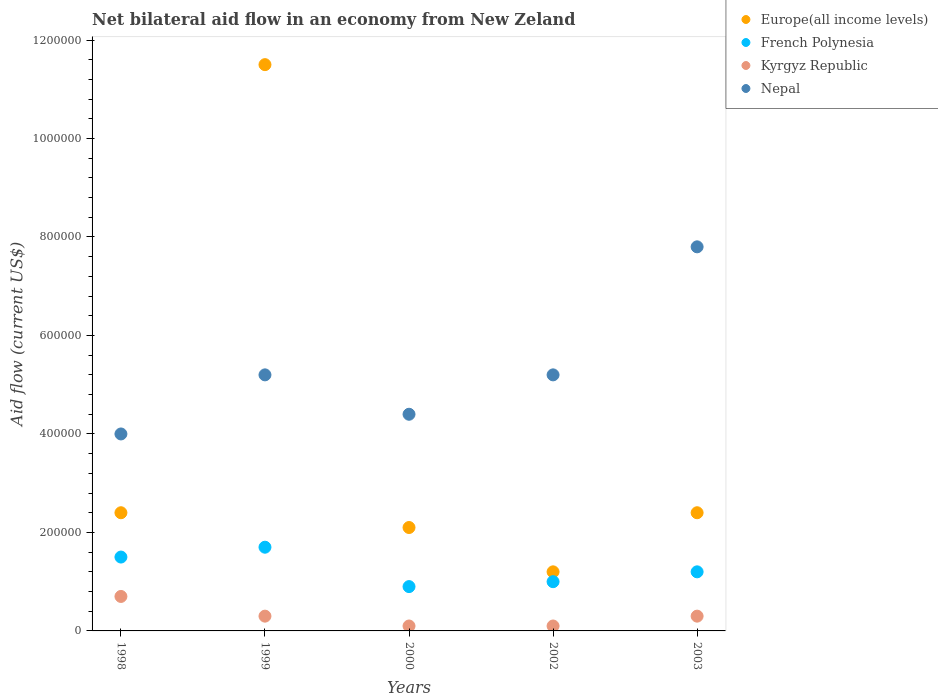Is the number of dotlines equal to the number of legend labels?
Your response must be concise. Yes. What is the net bilateral aid flow in Nepal in 1999?
Keep it short and to the point. 5.20e+05. Across all years, what is the maximum net bilateral aid flow in Kyrgyz Republic?
Provide a short and direct response. 7.00e+04. Across all years, what is the minimum net bilateral aid flow in Nepal?
Offer a very short reply. 4.00e+05. In which year was the net bilateral aid flow in Nepal minimum?
Offer a very short reply. 1998. What is the total net bilateral aid flow in Europe(all income levels) in the graph?
Your response must be concise. 1.96e+06. What is the difference between the net bilateral aid flow in French Polynesia in 2002 and the net bilateral aid flow in Nepal in 1999?
Your answer should be compact. -4.20e+05. What is the average net bilateral aid flow in Kyrgyz Republic per year?
Provide a short and direct response. 3.00e+04. In the year 2000, what is the difference between the net bilateral aid flow in French Polynesia and net bilateral aid flow in Europe(all income levels)?
Offer a very short reply. -1.20e+05. What is the ratio of the net bilateral aid flow in Kyrgyz Republic in 2000 to that in 2003?
Provide a short and direct response. 0.33. Is the net bilateral aid flow in Kyrgyz Republic in 2002 less than that in 2003?
Provide a short and direct response. Yes. What is the difference between the highest and the second highest net bilateral aid flow in French Polynesia?
Your answer should be very brief. 2.00e+04. What is the difference between the highest and the lowest net bilateral aid flow in Kyrgyz Republic?
Make the answer very short. 6.00e+04. In how many years, is the net bilateral aid flow in Nepal greater than the average net bilateral aid flow in Nepal taken over all years?
Your answer should be very brief. 1. Is it the case that in every year, the sum of the net bilateral aid flow in Nepal and net bilateral aid flow in Europe(all income levels)  is greater than the net bilateral aid flow in Kyrgyz Republic?
Provide a succinct answer. Yes. Does the net bilateral aid flow in Europe(all income levels) monotonically increase over the years?
Your answer should be very brief. No. Is the net bilateral aid flow in French Polynesia strictly greater than the net bilateral aid flow in Europe(all income levels) over the years?
Your answer should be compact. No. How many dotlines are there?
Ensure brevity in your answer.  4. What is the difference between two consecutive major ticks on the Y-axis?
Offer a very short reply. 2.00e+05. Does the graph contain grids?
Ensure brevity in your answer.  No. Where does the legend appear in the graph?
Keep it short and to the point. Top right. What is the title of the graph?
Offer a terse response. Net bilateral aid flow in an economy from New Zeland. What is the label or title of the X-axis?
Give a very brief answer. Years. What is the Aid flow (current US$) in Kyrgyz Republic in 1998?
Your response must be concise. 7.00e+04. What is the Aid flow (current US$) in Europe(all income levels) in 1999?
Your answer should be compact. 1.15e+06. What is the Aid flow (current US$) in French Polynesia in 1999?
Offer a terse response. 1.70e+05. What is the Aid flow (current US$) of Kyrgyz Republic in 1999?
Provide a succinct answer. 3.00e+04. What is the Aid flow (current US$) of Nepal in 1999?
Provide a succinct answer. 5.20e+05. What is the Aid flow (current US$) of Kyrgyz Republic in 2000?
Offer a terse response. 10000. What is the Aid flow (current US$) of French Polynesia in 2002?
Provide a short and direct response. 1.00e+05. What is the Aid flow (current US$) of Kyrgyz Republic in 2002?
Ensure brevity in your answer.  10000. What is the Aid flow (current US$) in Nepal in 2002?
Keep it short and to the point. 5.20e+05. What is the Aid flow (current US$) in Nepal in 2003?
Your answer should be compact. 7.80e+05. Across all years, what is the maximum Aid flow (current US$) of Europe(all income levels)?
Ensure brevity in your answer.  1.15e+06. Across all years, what is the maximum Aid flow (current US$) of French Polynesia?
Give a very brief answer. 1.70e+05. Across all years, what is the maximum Aid flow (current US$) of Kyrgyz Republic?
Offer a very short reply. 7.00e+04. Across all years, what is the maximum Aid flow (current US$) in Nepal?
Offer a terse response. 7.80e+05. Across all years, what is the minimum Aid flow (current US$) in French Polynesia?
Offer a very short reply. 9.00e+04. Across all years, what is the minimum Aid flow (current US$) in Kyrgyz Republic?
Keep it short and to the point. 10000. What is the total Aid flow (current US$) of Europe(all income levels) in the graph?
Your response must be concise. 1.96e+06. What is the total Aid flow (current US$) in French Polynesia in the graph?
Offer a very short reply. 6.30e+05. What is the total Aid flow (current US$) of Kyrgyz Republic in the graph?
Keep it short and to the point. 1.50e+05. What is the total Aid flow (current US$) of Nepal in the graph?
Give a very brief answer. 2.66e+06. What is the difference between the Aid flow (current US$) in Europe(all income levels) in 1998 and that in 1999?
Your response must be concise. -9.10e+05. What is the difference between the Aid flow (current US$) of Kyrgyz Republic in 1998 and that in 1999?
Keep it short and to the point. 4.00e+04. What is the difference between the Aid flow (current US$) in Nepal in 1998 and that in 1999?
Your response must be concise. -1.20e+05. What is the difference between the Aid flow (current US$) in French Polynesia in 1998 and that in 2000?
Provide a short and direct response. 6.00e+04. What is the difference between the Aid flow (current US$) of Kyrgyz Republic in 1998 and that in 2000?
Give a very brief answer. 6.00e+04. What is the difference between the Aid flow (current US$) in Nepal in 1998 and that in 2000?
Ensure brevity in your answer.  -4.00e+04. What is the difference between the Aid flow (current US$) of Europe(all income levels) in 1998 and that in 2002?
Your answer should be compact. 1.20e+05. What is the difference between the Aid flow (current US$) of French Polynesia in 1998 and that in 2002?
Your answer should be very brief. 5.00e+04. What is the difference between the Aid flow (current US$) in Kyrgyz Republic in 1998 and that in 2002?
Give a very brief answer. 6.00e+04. What is the difference between the Aid flow (current US$) of Nepal in 1998 and that in 2002?
Your answer should be compact. -1.20e+05. What is the difference between the Aid flow (current US$) of Nepal in 1998 and that in 2003?
Offer a terse response. -3.80e+05. What is the difference between the Aid flow (current US$) in Europe(all income levels) in 1999 and that in 2000?
Offer a terse response. 9.40e+05. What is the difference between the Aid flow (current US$) in French Polynesia in 1999 and that in 2000?
Your answer should be compact. 8.00e+04. What is the difference between the Aid flow (current US$) in Kyrgyz Republic in 1999 and that in 2000?
Your response must be concise. 2.00e+04. What is the difference between the Aid flow (current US$) of Europe(all income levels) in 1999 and that in 2002?
Your response must be concise. 1.03e+06. What is the difference between the Aid flow (current US$) in Nepal in 1999 and that in 2002?
Offer a terse response. 0. What is the difference between the Aid flow (current US$) of Europe(all income levels) in 1999 and that in 2003?
Offer a very short reply. 9.10e+05. What is the difference between the Aid flow (current US$) of French Polynesia in 1999 and that in 2003?
Provide a short and direct response. 5.00e+04. What is the difference between the Aid flow (current US$) in Kyrgyz Republic in 1999 and that in 2003?
Offer a terse response. 0. What is the difference between the Aid flow (current US$) of Europe(all income levels) in 2000 and that in 2002?
Offer a terse response. 9.00e+04. What is the difference between the Aid flow (current US$) of French Polynesia in 2000 and that in 2002?
Make the answer very short. -10000. What is the difference between the Aid flow (current US$) in Kyrgyz Republic in 2000 and that in 2002?
Provide a succinct answer. 0. What is the difference between the Aid flow (current US$) in Nepal in 2000 and that in 2002?
Make the answer very short. -8.00e+04. What is the difference between the Aid flow (current US$) of Kyrgyz Republic in 2000 and that in 2003?
Offer a very short reply. -2.00e+04. What is the difference between the Aid flow (current US$) of Nepal in 2000 and that in 2003?
Provide a short and direct response. -3.40e+05. What is the difference between the Aid flow (current US$) in Europe(all income levels) in 2002 and that in 2003?
Ensure brevity in your answer.  -1.20e+05. What is the difference between the Aid flow (current US$) in Nepal in 2002 and that in 2003?
Provide a succinct answer. -2.60e+05. What is the difference between the Aid flow (current US$) in Europe(all income levels) in 1998 and the Aid flow (current US$) in French Polynesia in 1999?
Give a very brief answer. 7.00e+04. What is the difference between the Aid flow (current US$) of Europe(all income levels) in 1998 and the Aid flow (current US$) of Nepal in 1999?
Offer a terse response. -2.80e+05. What is the difference between the Aid flow (current US$) in French Polynesia in 1998 and the Aid flow (current US$) in Kyrgyz Republic in 1999?
Keep it short and to the point. 1.20e+05. What is the difference between the Aid flow (current US$) in French Polynesia in 1998 and the Aid flow (current US$) in Nepal in 1999?
Keep it short and to the point. -3.70e+05. What is the difference between the Aid flow (current US$) in Kyrgyz Republic in 1998 and the Aid flow (current US$) in Nepal in 1999?
Your answer should be very brief. -4.50e+05. What is the difference between the Aid flow (current US$) in Europe(all income levels) in 1998 and the Aid flow (current US$) in Nepal in 2000?
Offer a very short reply. -2.00e+05. What is the difference between the Aid flow (current US$) in French Polynesia in 1998 and the Aid flow (current US$) in Nepal in 2000?
Ensure brevity in your answer.  -2.90e+05. What is the difference between the Aid flow (current US$) in Kyrgyz Republic in 1998 and the Aid flow (current US$) in Nepal in 2000?
Your answer should be compact. -3.70e+05. What is the difference between the Aid flow (current US$) of Europe(all income levels) in 1998 and the Aid flow (current US$) of Nepal in 2002?
Your response must be concise. -2.80e+05. What is the difference between the Aid flow (current US$) in French Polynesia in 1998 and the Aid flow (current US$) in Kyrgyz Republic in 2002?
Your response must be concise. 1.40e+05. What is the difference between the Aid flow (current US$) in French Polynesia in 1998 and the Aid flow (current US$) in Nepal in 2002?
Offer a very short reply. -3.70e+05. What is the difference between the Aid flow (current US$) of Kyrgyz Republic in 1998 and the Aid flow (current US$) of Nepal in 2002?
Offer a terse response. -4.50e+05. What is the difference between the Aid flow (current US$) in Europe(all income levels) in 1998 and the Aid flow (current US$) in French Polynesia in 2003?
Provide a succinct answer. 1.20e+05. What is the difference between the Aid flow (current US$) of Europe(all income levels) in 1998 and the Aid flow (current US$) of Nepal in 2003?
Your response must be concise. -5.40e+05. What is the difference between the Aid flow (current US$) of French Polynesia in 1998 and the Aid flow (current US$) of Nepal in 2003?
Give a very brief answer. -6.30e+05. What is the difference between the Aid flow (current US$) in Kyrgyz Republic in 1998 and the Aid flow (current US$) in Nepal in 2003?
Provide a succinct answer. -7.10e+05. What is the difference between the Aid flow (current US$) of Europe(all income levels) in 1999 and the Aid flow (current US$) of French Polynesia in 2000?
Provide a short and direct response. 1.06e+06. What is the difference between the Aid flow (current US$) of Europe(all income levels) in 1999 and the Aid flow (current US$) of Kyrgyz Republic in 2000?
Your answer should be very brief. 1.14e+06. What is the difference between the Aid flow (current US$) of Europe(all income levels) in 1999 and the Aid flow (current US$) of Nepal in 2000?
Offer a very short reply. 7.10e+05. What is the difference between the Aid flow (current US$) of French Polynesia in 1999 and the Aid flow (current US$) of Nepal in 2000?
Make the answer very short. -2.70e+05. What is the difference between the Aid flow (current US$) of Kyrgyz Republic in 1999 and the Aid flow (current US$) of Nepal in 2000?
Offer a very short reply. -4.10e+05. What is the difference between the Aid flow (current US$) of Europe(all income levels) in 1999 and the Aid flow (current US$) of French Polynesia in 2002?
Your answer should be compact. 1.05e+06. What is the difference between the Aid flow (current US$) in Europe(all income levels) in 1999 and the Aid flow (current US$) in Kyrgyz Republic in 2002?
Offer a very short reply. 1.14e+06. What is the difference between the Aid flow (current US$) of Europe(all income levels) in 1999 and the Aid flow (current US$) of Nepal in 2002?
Provide a succinct answer. 6.30e+05. What is the difference between the Aid flow (current US$) in French Polynesia in 1999 and the Aid flow (current US$) in Nepal in 2002?
Provide a short and direct response. -3.50e+05. What is the difference between the Aid flow (current US$) in Kyrgyz Republic in 1999 and the Aid flow (current US$) in Nepal in 2002?
Give a very brief answer. -4.90e+05. What is the difference between the Aid flow (current US$) of Europe(all income levels) in 1999 and the Aid flow (current US$) of French Polynesia in 2003?
Offer a terse response. 1.03e+06. What is the difference between the Aid flow (current US$) of Europe(all income levels) in 1999 and the Aid flow (current US$) of Kyrgyz Republic in 2003?
Keep it short and to the point. 1.12e+06. What is the difference between the Aid flow (current US$) in French Polynesia in 1999 and the Aid flow (current US$) in Kyrgyz Republic in 2003?
Offer a terse response. 1.40e+05. What is the difference between the Aid flow (current US$) in French Polynesia in 1999 and the Aid flow (current US$) in Nepal in 2003?
Provide a succinct answer. -6.10e+05. What is the difference between the Aid flow (current US$) of Kyrgyz Republic in 1999 and the Aid flow (current US$) of Nepal in 2003?
Make the answer very short. -7.50e+05. What is the difference between the Aid flow (current US$) of Europe(all income levels) in 2000 and the Aid flow (current US$) of Kyrgyz Republic in 2002?
Keep it short and to the point. 2.00e+05. What is the difference between the Aid flow (current US$) in Europe(all income levels) in 2000 and the Aid flow (current US$) in Nepal in 2002?
Offer a terse response. -3.10e+05. What is the difference between the Aid flow (current US$) in French Polynesia in 2000 and the Aid flow (current US$) in Nepal in 2002?
Ensure brevity in your answer.  -4.30e+05. What is the difference between the Aid flow (current US$) in Kyrgyz Republic in 2000 and the Aid flow (current US$) in Nepal in 2002?
Give a very brief answer. -5.10e+05. What is the difference between the Aid flow (current US$) in Europe(all income levels) in 2000 and the Aid flow (current US$) in French Polynesia in 2003?
Offer a very short reply. 9.00e+04. What is the difference between the Aid flow (current US$) in Europe(all income levels) in 2000 and the Aid flow (current US$) in Kyrgyz Republic in 2003?
Your response must be concise. 1.80e+05. What is the difference between the Aid flow (current US$) in Europe(all income levels) in 2000 and the Aid flow (current US$) in Nepal in 2003?
Give a very brief answer. -5.70e+05. What is the difference between the Aid flow (current US$) in French Polynesia in 2000 and the Aid flow (current US$) in Kyrgyz Republic in 2003?
Make the answer very short. 6.00e+04. What is the difference between the Aid flow (current US$) of French Polynesia in 2000 and the Aid flow (current US$) of Nepal in 2003?
Keep it short and to the point. -6.90e+05. What is the difference between the Aid flow (current US$) of Kyrgyz Republic in 2000 and the Aid flow (current US$) of Nepal in 2003?
Provide a succinct answer. -7.70e+05. What is the difference between the Aid flow (current US$) in Europe(all income levels) in 2002 and the Aid flow (current US$) in Kyrgyz Republic in 2003?
Your response must be concise. 9.00e+04. What is the difference between the Aid flow (current US$) in Europe(all income levels) in 2002 and the Aid flow (current US$) in Nepal in 2003?
Make the answer very short. -6.60e+05. What is the difference between the Aid flow (current US$) of French Polynesia in 2002 and the Aid flow (current US$) of Kyrgyz Republic in 2003?
Your answer should be compact. 7.00e+04. What is the difference between the Aid flow (current US$) in French Polynesia in 2002 and the Aid flow (current US$) in Nepal in 2003?
Provide a short and direct response. -6.80e+05. What is the difference between the Aid flow (current US$) of Kyrgyz Republic in 2002 and the Aid flow (current US$) of Nepal in 2003?
Make the answer very short. -7.70e+05. What is the average Aid flow (current US$) of Europe(all income levels) per year?
Your response must be concise. 3.92e+05. What is the average Aid flow (current US$) in French Polynesia per year?
Your answer should be very brief. 1.26e+05. What is the average Aid flow (current US$) in Nepal per year?
Keep it short and to the point. 5.32e+05. In the year 1998, what is the difference between the Aid flow (current US$) in Europe(all income levels) and Aid flow (current US$) in Kyrgyz Republic?
Offer a very short reply. 1.70e+05. In the year 1998, what is the difference between the Aid flow (current US$) in French Polynesia and Aid flow (current US$) in Nepal?
Your response must be concise. -2.50e+05. In the year 1998, what is the difference between the Aid flow (current US$) in Kyrgyz Republic and Aid flow (current US$) in Nepal?
Offer a very short reply. -3.30e+05. In the year 1999, what is the difference between the Aid flow (current US$) in Europe(all income levels) and Aid flow (current US$) in French Polynesia?
Provide a succinct answer. 9.80e+05. In the year 1999, what is the difference between the Aid flow (current US$) of Europe(all income levels) and Aid flow (current US$) of Kyrgyz Republic?
Make the answer very short. 1.12e+06. In the year 1999, what is the difference between the Aid flow (current US$) of Europe(all income levels) and Aid flow (current US$) of Nepal?
Keep it short and to the point. 6.30e+05. In the year 1999, what is the difference between the Aid flow (current US$) in French Polynesia and Aid flow (current US$) in Nepal?
Your answer should be compact. -3.50e+05. In the year 1999, what is the difference between the Aid flow (current US$) of Kyrgyz Republic and Aid flow (current US$) of Nepal?
Offer a very short reply. -4.90e+05. In the year 2000, what is the difference between the Aid flow (current US$) in Europe(all income levels) and Aid flow (current US$) in French Polynesia?
Ensure brevity in your answer.  1.20e+05. In the year 2000, what is the difference between the Aid flow (current US$) of Europe(all income levels) and Aid flow (current US$) of Nepal?
Your answer should be very brief. -2.30e+05. In the year 2000, what is the difference between the Aid flow (current US$) in French Polynesia and Aid flow (current US$) in Nepal?
Provide a short and direct response. -3.50e+05. In the year 2000, what is the difference between the Aid flow (current US$) in Kyrgyz Republic and Aid flow (current US$) in Nepal?
Offer a terse response. -4.30e+05. In the year 2002, what is the difference between the Aid flow (current US$) in Europe(all income levels) and Aid flow (current US$) in French Polynesia?
Give a very brief answer. 2.00e+04. In the year 2002, what is the difference between the Aid flow (current US$) in Europe(all income levels) and Aid flow (current US$) in Kyrgyz Republic?
Make the answer very short. 1.10e+05. In the year 2002, what is the difference between the Aid flow (current US$) in Europe(all income levels) and Aid flow (current US$) in Nepal?
Provide a succinct answer. -4.00e+05. In the year 2002, what is the difference between the Aid flow (current US$) of French Polynesia and Aid flow (current US$) of Nepal?
Make the answer very short. -4.20e+05. In the year 2002, what is the difference between the Aid flow (current US$) in Kyrgyz Republic and Aid flow (current US$) in Nepal?
Your answer should be very brief. -5.10e+05. In the year 2003, what is the difference between the Aid flow (current US$) of Europe(all income levels) and Aid flow (current US$) of Nepal?
Make the answer very short. -5.40e+05. In the year 2003, what is the difference between the Aid flow (current US$) in French Polynesia and Aid flow (current US$) in Kyrgyz Republic?
Your response must be concise. 9.00e+04. In the year 2003, what is the difference between the Aid flow (current US$) of French Polynesia and Aid flow (current US$) of Nepal?
Provide a short and direct response. -6.60e+05. In the year 2003, what is the difference between the Aid flow (current US$) in Kyrgyz Republic and Aid flow (current US$) in Nepal?
Offer a terse response. -7.50e+05. What is the ratio of the Aid flow (current US$) in Europe(all income levels) in 1998 to that in 1999?
Offer a very short reply. 0.21. What is the ratio of the Aid flow (current US$) of French Polynesia in 1998 to that in 1999?
Your answer should be very brief. 0.88. What is the ratio of the Aid flow (current US$) of Kyrgyz Republic in 1998 to that in 1999?
Make the answer very short. 2.33. What is the ratio of the Aid flow (current US$) of Nepal in 1998 to that in 1999?
Your response must be concise. 0.77. What is the ratio of the Aid flow (current US$) in Europe(all income levels) in 1998 to that in 2000?
Your response must be concise. 1.14. What is the ratio of the Aid flow (current US$) of Europe(all income levels) in 1998 to that in 2002?
Your response must be concise. 2. What is the ratio of the Aid flow (current US$) in Kyrgyz Republic in 1998 to that in 2002?
Provide a short and direct response. 7. What is the ratio of the Aid flow (current US$) in Nepal in 1998 to that in 2002?
Keep it short and to the point. 0.77. What is the ratio of the Aid flow (current US$) of Kyrgyz Republic in 1998 to that in 2003?
Offer a terse response. 2.33. What is the ratio of the Aid flow (current US$) of Nepal in 1998 to that in 2003?
Your answer should be compact. 0.51. What is the ratio of the Aid flow (current US$) in Europe(all income levels) in 1999 to that in 2000?
Keep it short and to the point. 5.48. What is the ratio of the Aid flow (current US$) of French Polynesia in 1999 to that in 2000?
Your response must be concise. 1.89. What is the ratio of the Aid flow (current US$) in Nepal in 1999 to that in 2000?
Your response must be concise. 1.18. What is the ratio of the Aid flow (current US$) of Europe(all income levels) in 1999 to that in 2002?
Your response must be concise. 9.58. What is the ratio of the Aid flow (current US$) in French Polynesia in 1999 to that in 2002?
Your response must be concise. 1.7. What is the ratio of the Aid flow (current US$) in Nepal in 1999 to that in 2002?
Your response must be concise. 1. What is the ratio of the Aid flow (current US$) of Europe(all income levels) in 1999 to that in 2003?
Provide a succinct answer. 4.79. What is the ratio of the Aid flow (current US$) in French Polynesia in 1999 to that in 2003?
Your answer should be compact. 1.42. What is the ratio of the Aid flow (current US$) in Nepal in 1999 to that in 2003?
Your answer should be compact. 0.67. What is the ratio of the Aid flow (current US$) of Nepal in 2000 to that in 2002?
Your response must be concise. 0.85. What is the ratio of the Aid flow (current US$) of Europe(all income levels) in 2000 to that in 2003?
Offer a terse response. 0.88. What is the ratio of the Aid flow (current US$) of French Polynesia in 2000 to that in 2003?
Offer a terse response. 0.75. What is the ratio of the Aid flow (current US$) in Nepal in 2000 to that in 2003?
Provide a succinct answer. 0.56. What is the ratio of the Aid flow (current US$) of French Polynesia in 2002 to that in 2003?
Your answer should be very brief. 0.83. What is the ratio of the Aid flow (current US$) in Kyrgyz Republic in 2002 to that in 2003?
Offer a very short reply. 0.33. What is the ratio of the Aid flow (current US$) of Nepal in 2002 to that in 2003?
Make the answer very short. 0.67. What is the difference between the highest and the second highest Aid flow (current US$) in Europe(all income levels)?
Your answer should be compact. 9.10e+05. What is the difference between the highest and the second highest Aid flow (current US$) of Kyrgyz Republic?
Your answer should be very brief. 4.00e+04. What is the difference between the highest and the lowest Aid flow (current US$) of Europe(all income levels)?
Provide a short and direct response. 1.03e+06. What is the difference between the highest and the lowest Aid flow (current US$) in French Polynesia?
Provide a succinct answer. 8.00e+04. What is the difference between the highest and the lowest Aid flow (current US$) in Nepal?
Keep it short and to the point. 3.80e+05. 